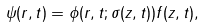<formula> <loc_0><loc_0><loc_500><loc_500>\psi ( { r } , t ) = \phi ( r , t ; \sigma ( z , t ) ) f ( z , t ) ,</formula> 